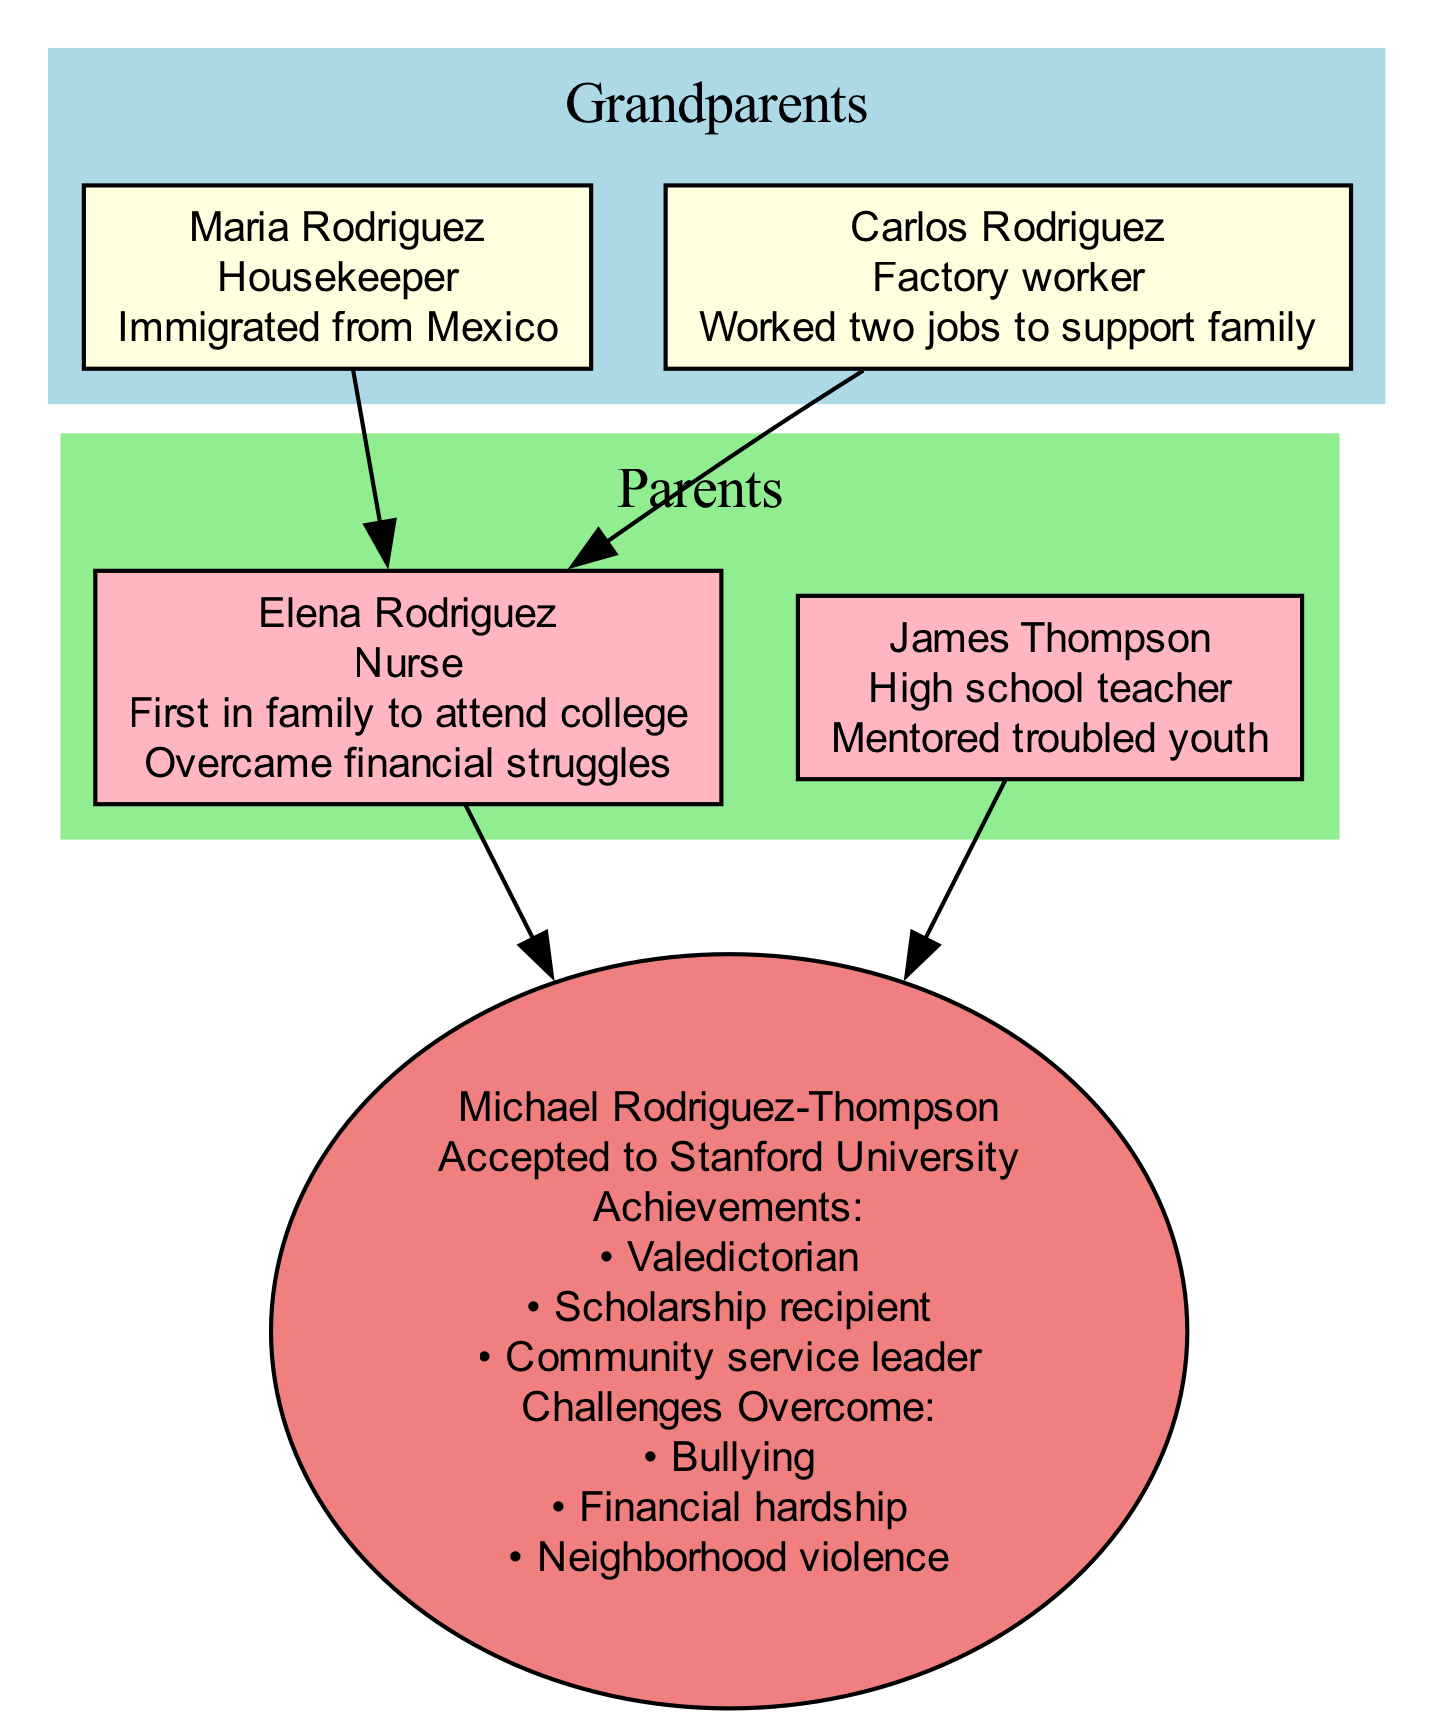What is the occupation of Michael Rodriguez-Thompson's father? The diagram indicates that Michael Rodriguez-Thompson's father is "James Thompson," whose occupation is labeled as "High school teacher." Thus, the answer is derived directly from the parent's information in the diagram.
Answer: High school teacher How many grandparents are listed in the family tree? The family tree includes two grandparents shown in the diagram: Maria Rodriguez and Carlos Rodriguez. Thus, by counting these nodes in the grandparents' section of the diagram, we find the total number is two.
Answer: 2 Who is the first person in the family to attend college? In the parent's section of the diagram, "Elena Rodriguez" is noted as "First in family to attend college." By referring specifically to the achievements and educational background provided, we can identify Elena as the key individual.
Answer: Elena Rodriguez What challenge did Michael Rodriguez-Thompson overcome that relates to his environment? One of the challenges listed under Michael Rodriguez-Thompson's "Challenges Overcome" is "Neighborhood violence." This refers to external factors in his environment, indicating an obstacle that he faced.
Answer: Neighborhood violence What is the relationship between Maria Rodriguez and Michael Rodriguez-Thompson? Maria Rodriguez is Michael's grandmother, as indicated in the family tree. The lineage from Maria to Michael can be traced through the parents section, establishing her role as his grandmother.
Answer: Grandmother Which achievement demonstrates Michael's leadership in the community? The achievement listed for Michael Rodriguez-Thompson is "Community service leader," which indicates his role and impact as a leader within his community. This achievement highlights his contributions beyond academic accomplishments.
Answer: Community service leader What occupation did Carlos Rodriguez hold? According to the data provided, Carlos Rodriguez was a "Factory worker." This information is explicitly stated under the grandparents' section of the diagram and gives insight into his profession.
Answer: Factory worker How did Elena Rodriguez's education impact her family? Elena Rodriguez's education is significant as she was noted as "First in family to attend college." This accomplishment likely served as a role model for future generations, including her son, Michael. The impact can be inferred as a motivational journey for the family.
Answer: Motivational journey How many challenges did Michael Rodriguez-Thompson overcome? Michael Rodriguez-Thompson overcame three challenges according to the "Challenges Overcome" section: bullying, financial hardship, and neighborhood violence. By counting these items, we find that the total is three.
Answer: 3 